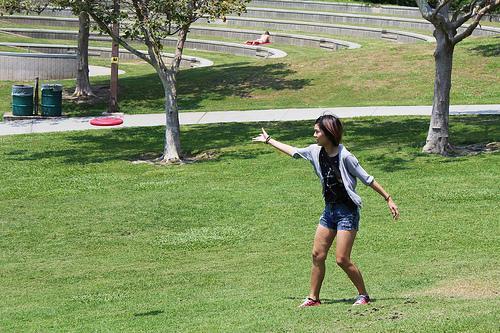How many people are in the picture?
Give a very brief answer. 2. 